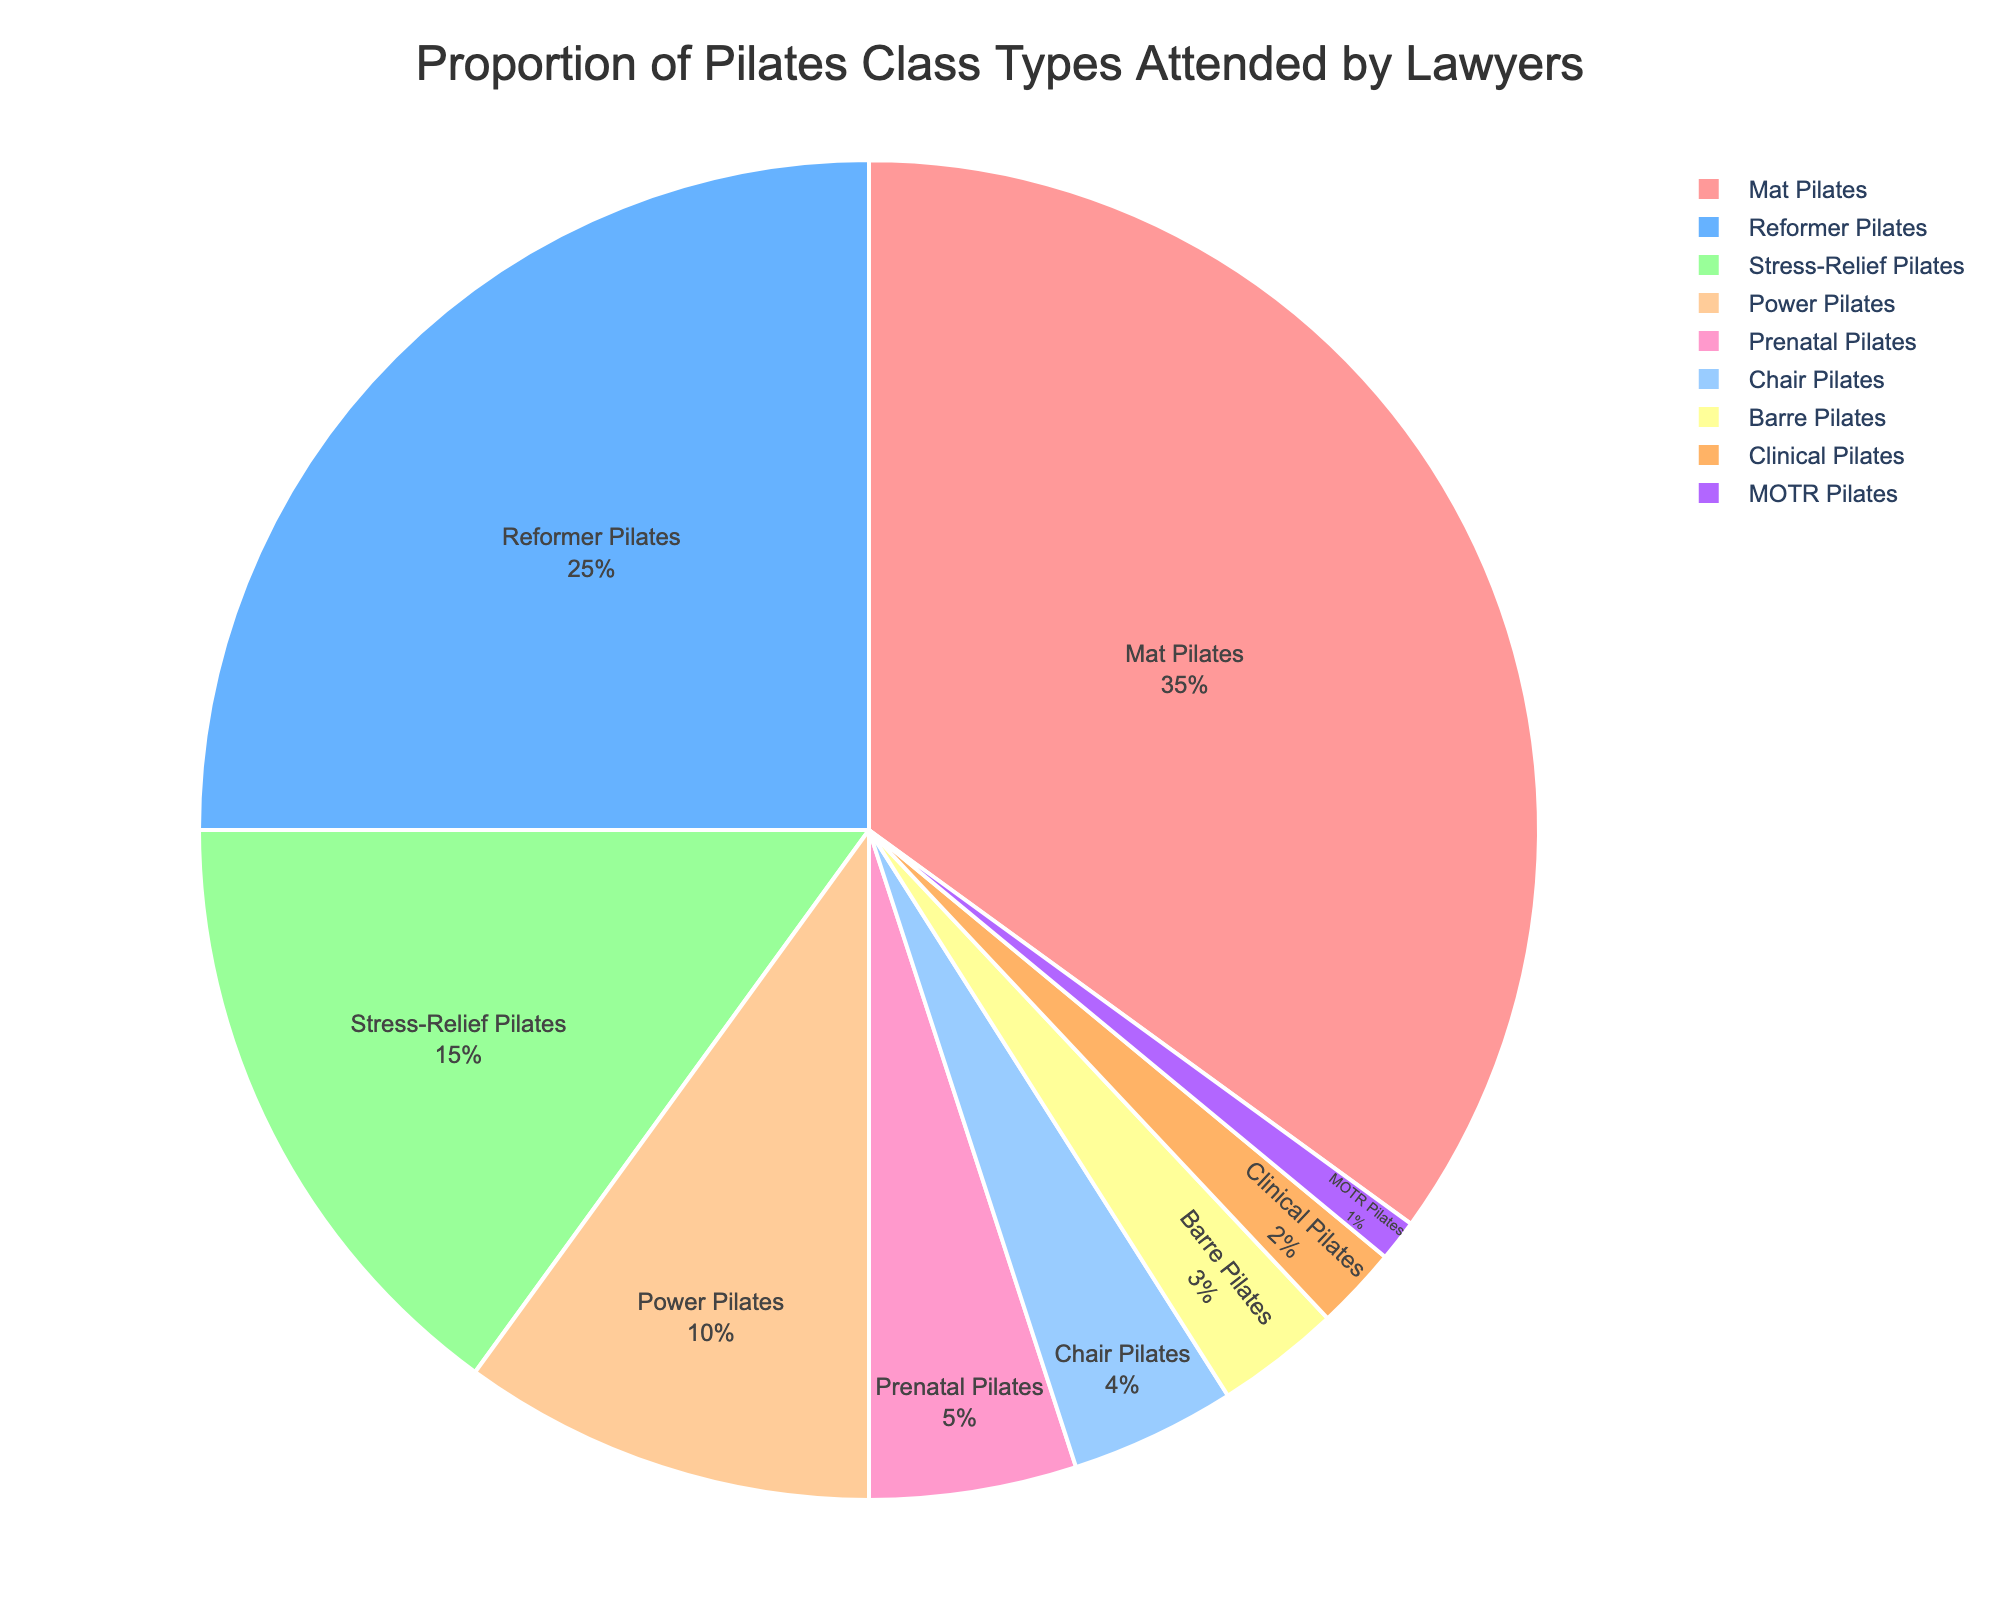What's the class type with the highest proportion? By looking at the largest section of the pie chart, the class with the highest proportion can be identified.
Answer: Mat Pilates What's the combined percentage of Power Pilates and Clinical Pilates? First, identify the percentage for Power Pilates (10%) and Clinical Pilates (2%) from the chart. Then, add these percentages together: 10% + 2% = 12%.
Answer: 12% Which classes have a smaller proportion than Stress-Relief Pilates? From the chart, identify the classes with percentages lower than Stress-Relief Pilates (15%): Power Pilates (10%), Prenatal Pilates (5%), Chair Pilates (4%), Barre Pilates (3%), Clinical Pilates (2%), and MOTR Pilates (1%).
Answer: Power Pilates, Prenatal Pilates, Chair Pilates, Barre Pilates, Clinical Pilates, MOTR Pilates How much higher is the percentage of Reformer Pilates compared to Chair Pilates? Identify the percentage of Reformer Pilates (25%) and Chair Pilates (4%) from the chart. Subtract the smaller percentage from the larger one: 25% - 4% = 21%.
Answer: 21% What is the total percentage of classes that have a proportion greater than 10%? Identify classes with percentages greater than 10%: Mat Pilates (35%), Reformer Pilates (25%), and Stress-Relief Pilates (15%). Sum these percentages: 35% + 25% + 15% = 75%.
Answer: 75% Which Pilates class type is represented by the second-largest segment? By observing the second-largest section of the pie chart, Reformer Pilates, with 25%, is identified as the second-largest segment.
Answer: Reformer Pilates What proportion does Prenatal Pilates and MOTR Pilates together represent? Identify the percentage for Prenatal Pilates (5%) and MOTR Pilates (1%) from the chart. Add these percentages together: 5% + 1% = 6%.
Answer: 6% How do the proportions of Chair Pilates and Barre Pilates compare visually? Visually, the slice for Chair Pilates is slightly larger than that for Barre Pilates, indicating a higher proportion. Chair Pilates (4%) compared to Barre Pilates (3%).
Answer: Chair Pilates is larger Which class type has the second smallest proportion, and what is it? Identify the segment with the second smallest size after MOTR Pilates (1%), which is Clinical Pilates with 2%.
Answer: Clinical Pilates with 2% What is the average proportion of the top three most attended Pilates classes? Identify the percentages for the top three classes: Mat Pilates (35%), Reformer Pilates (25%), and Stress-Relief Pilates (15%). Sum these percentages and divide by three: (35% + 25% + 15%) / 3 = 25%.
Answer: 25% 